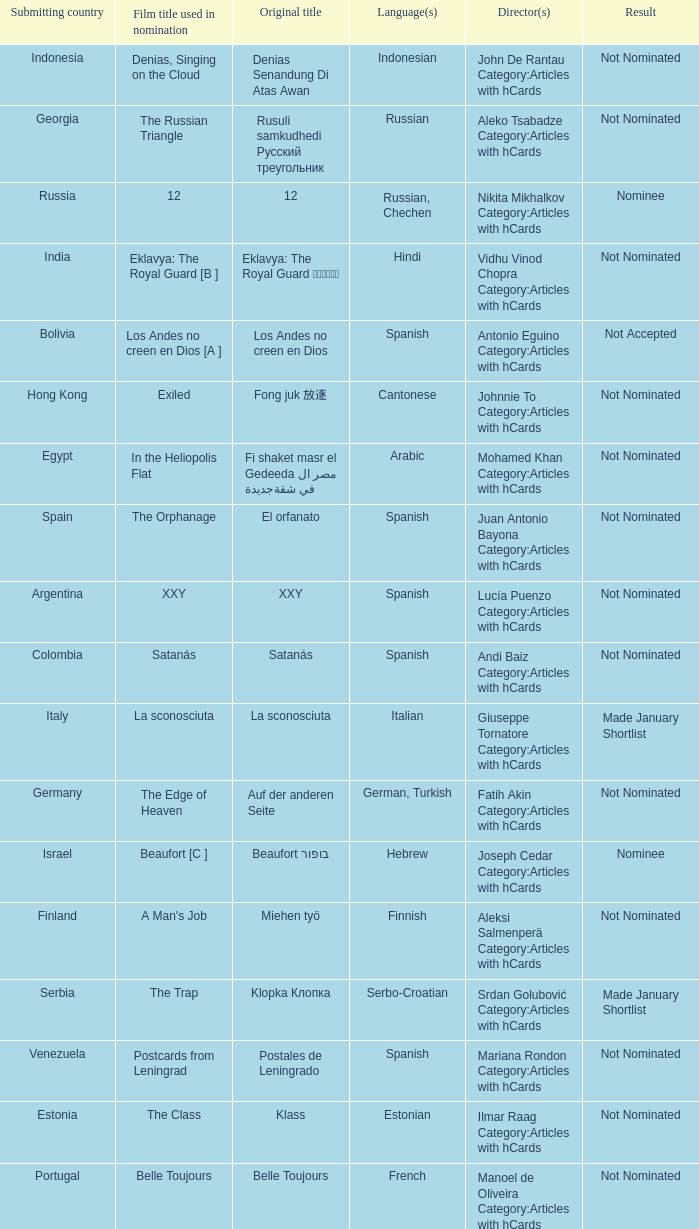What country submitted miehen työ? Finland. 